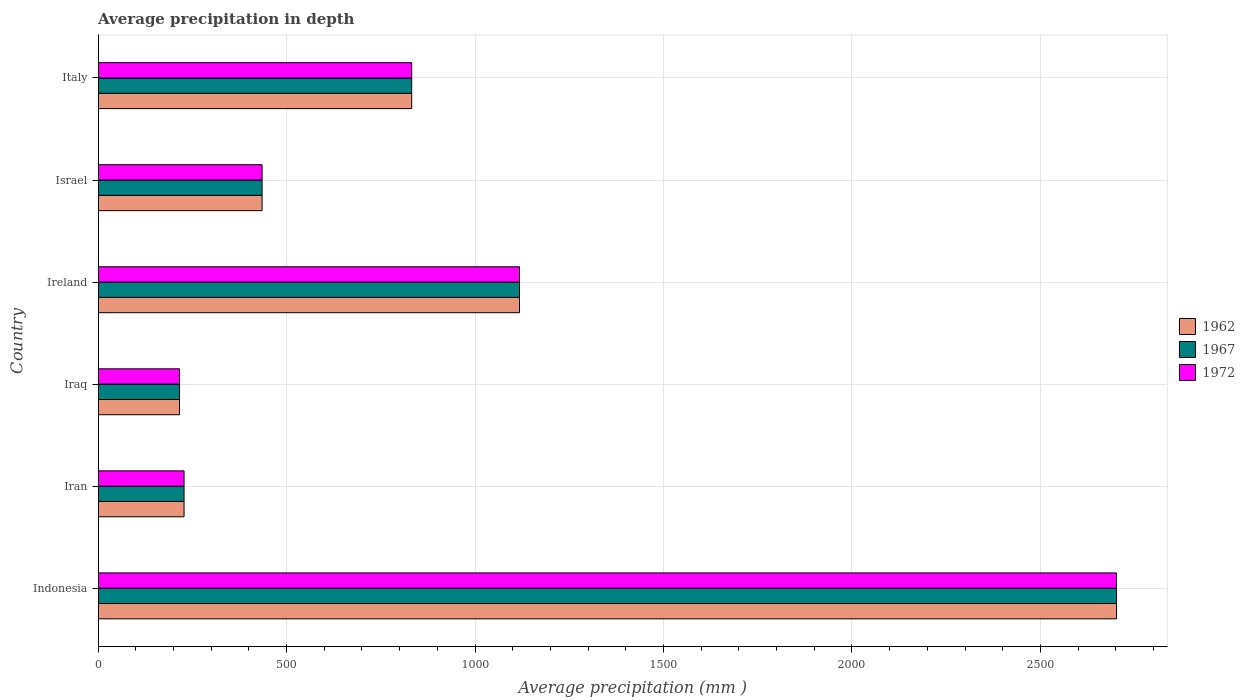How many groups of bars are there?
Give a very brief answer. 6. Are the number of bars on each tick of the Y-axis equal?
Provide a succinct answer. Yes. What is the label of the 6th group of bars from the top?
Provide a short and direct response. Indonesia. In how many cases, is the number of bars for a given country not equal to the number of legend labels?
Ensure brevity in your answer.  0. What is the average precipitation in 1962 in Indonesia?
Provide a succinct answer. 2702. Across all countries, what is the maximum average precipitation in 1967?
Provide a succinct answer. 2702. Across all countries, what is the minimum average precipitation in 1972?
Make the answer very short. 216. In which country was the average precipitation in 1962 minimum?
Provide a short and direct response. Iraq. What is the total average precipitation in 1967 in the graph?
Give a very brief answer. 5531. What is the difference between the average precipitation in 1962 in Iraq and that in Italy?
Make the answer very short. -616. What is the difference between the average precipitation in 1972 in Israel and the average precipitation in 1967 in Iraq?
Your response must be concise. 219. What is the average average precipitation in 1967 per country?
Provide a succinct answer. 921.83. What is the difference between the average precipitation in 1972 and average precipitation in 1962 in Iran?
Give a very brief answer. 0. What is the ratio of the average precipitation in 1962 in Iran to that in Israel?
Your answer should be compact. 0.52. What is the difference between the highest and the second highest average precipitation in 1962?
Keep it short and to the point. 1584. What is the difference between the highest and the lowest average precipitation in 1967?
Keep it short and to the point. 2486. Is the sum of the average precipitation in 1962 in Iran and Iraq greater than the maximum average precipitation in 1967 across all countries?
Provide a succinct answer. No. What does the 1st bar from the bottom in Iran represents?
Your answer should be very brief. 1962. How many bars are there?
Ensure brevity in your answer.  18. Are all the bars in the graph horizontal?
Keep it short and to the point. Yes. How many countries are there in the graph?
Offer a very short reply. 6. Does the graph contain any zero values?
Your response must be concise. No. Does the graph contain grids?
Offer a very short reply. Yes. How many legend labels are there?
Your response must be concise. 3. How are the legend labels stacked?
Offer a very short reply. Vertical. What is the title of the graph?
Give a very brief answer. Average precipitation in depth. Does "1997" appear as one of the legend labels in the graph?
Provide a succinct answer. No. What is the label or title of the X-axis?
Make the answer very short. Average precipitation (mm ). What is the label or title of the Y-axis?
Offer a terse response. Country. What is the Average precipitation (mm ) of 1962 in Indonesia?
Your answer should be very brief. 2702. What is the Average precipitation (mm ) in 1967 in Indonesia?
Give a very brief answer. 2702. What is the Average precipitation (mm ) of 1972 in Indonesia?
Offer a very short reply. 2702. What is the Average precipitation (mm ) of 1962 in Iran?
Keep it short and to the point. 228. What is the Average precipitation (mm ) of 1967 in Iran?
Your answer should be very brief. 228. What is the Average precipitation (mm ) in 1972 in Iran?
Ensure brevity in your answer.  228. What is the Average precipitation (mm ) of 1962 in Iraq?
Offer a very short reply. 216. What is the Average precipitation (mm ) in 1967 in Iraq?
Give a very brief answer. 216. What is the Average precipitation (mm ) in 1972 in Iraq?
Offer a terse response. 216. What is the Average precipitation (mm ) of 1962 in Ireland?
Provide a succinct answer. 1118. What is the Average precipitation (mm ) of 1967 in Ireland?
Provide a succinct answer. 1118. What is the Average precipitation (mm ) of 1972 in Ireland?
Offer a very short reply. 1118. What is the Average precipitation (mm ) of 1962 in Israel?
Offer a very short reply. 435. What is the Average precipitation (mm ) of 1967 in Israel?
Provide a succinct answer. 435. What is the Average precipitation (mm ) in 1972 in Israel?
Offer a terse response. 435. What is the Average precipitation (mm ) in 1962 in Italy?
Make the answer very short. 832. What is the Average precipitation (mm ) of 1967 in Italy?
Provide a succinct answer. 832. What is the Average precipitation (mm ) of 1972 in Italy?
Provide a succinct answer. 832. Across all countries, what is the maximum Average precipitation (mm ) in 1962?
Offer a very short reply. 2702. Across all countries, what is the maximum Average precipitation (mm ) of 1967?
Offer a very short reply. 2702. Across all countries, what is the maximum Average precipitation (mm ) of 1972?
Offer a very short reply. 2702. Across all countries, what is the minimum Average precipitation (mm ) of 1962?
Give a very brief answer. 216. Across all countries, what is the minimum Average precipitation (mm ) of 1967?
Provide a short and direct response. 216. Across all countries, what is the minimum Average precipitation (mm ) in 1972?
Give a very brief answer. 216. What is the total Average precipitation (mm ) of 1962 in the graph?
Make the answer very short. 5531. What is the total Average precipitation (mm ) in 1967 in the graph?
Give a very brief answer. 5531. What is the total Average precipitation (mm ) in 1972 in the graph?
Your answer should be compact. 5531. What is the difference between the Average precipitation (mm ) in 1962 in Indonesia and that in Iran?
Make the answer very short. 2474. What is the difference between the Average precipitation (mm ) in 1967 in Indonesia and that in Iran?
Provide a short and direct response. 2474. What is the difference between the Average precipitation (mm ) in 1972 in Indonesia and that in Iran?
Ensure brevity in your answer.  2474. What is the difference between the Average precipitation (mm ) of 1962 in Indonesia and that in Iraq?
Your answer should be compact. 2486. What is the difference between the Average precipitation (mm ) in 1967 in Indonesia and that in Iraq?
Your answer should be very brief. 2486. What is the difference between the Average precipitation (mm ) in 1972 in Indonesia and that in Iraq?
Make the answer very short. 2486. What is the difference between the Average precipitation (mm ) of 1962 in Indonesia and that in Ireland?
Provide a succinct answer. 1584. What is the difference between the Average precipitation (mm ) of 1967 in Indonesia and that in Ireland?
Offer a terse response. 1584. What is the difference between the Average precipitation (mm ) of 1972 in Indonesia and that in Ireland?
Provide a short and direct response. 1584. What is the difference between the Average precipitation (mm ) in 1962 in Indonesia and that in Israel?
Offer a very short reply. 2267. What is the difference between the Average precipitation (mm ) of 1967 in Indonesia and that in Israel?
Offer a very short reply. 2267. What is the difference between the Average precipitation (mm ) in 1972 in Indonesia and that in Israel?
Provide a succinct answer. 2267. What is the difference between the Average precipitation (mm ) of 1962 in Indonesia and that in Italy?
Offer a terse response. 1870. What is the difference between the Average precipitation (mm ) in 1967 in Indonesia and that in Italy?
Provide a succinct answer. 1870. What is the difference between the Average precipitation (mm ) in 1972 in Indonesia and that in Italy?
Offer a very short reply. 1870. What is the difference between the Average precipitation (mm ) in 1962 in Iran and that in Iraq?
Offer a terse response. 12. What is the difference between the Average precipitation (mm ) in 1967 in Iran and that in Iraq?
Give a very brief answer. 12. What is the difference between the Average precipitation (mm ) in 1962 in Iran and that in Ireland?
Offer a very short reply. -890. What is the difference between the Average precipitation (mm ) in 1967 in Iran and that in Ireland?
Ensure brevity in your answer.  -890. What is the difference between the Average precipitation (mm ) in 1972 in Iran and that in Ireland?
Make the answer very short. -890. What is the difference between the Average precipitation (mm ) of 1962 in Iran and that in Israel?
Offer a very short reply. -207. What is the difference between the Average precipitation (mm ) of 1967 in Iran and that in Israel?
Give a very brief answer. -207. What is the difference between the Average precipitation (mm ) of 1972 in Iran and that in Israel?
Provide a succinct answer. -207. What is the difference between the Average precipitation (mm ) in 1962 in Iran and that in Italy?
Provide a short and direct response. -604. What is the difference between the Average precipitation (mm ) in 1967 in Iran and that in Italy?
Provide a short and direct response. -604. What is the difference between the Average precipitation (mm ) in 1972 in Iran and that in Italy?
Offer a very short reply. -604. What is the difference between the Average precipitation (mm ) in 1962 in Iraq and that in Ireland?
Offer a very short reply. -902. What is the difference between the Average precipitation (mm ) of 1967 in Iraq and that in Ireland?
Provide a short and direct response. -902. What is the difference between the Average precipitation (mm ) of 1972 in Iraq and that in Ireland?
Keep it short and to the point. -902. What is the difference between the Average precipitation (mm ) in 1962 in Iraq and that in Israel?
Make the answer very short. -219. What is the difference between the Average precipitation (mm ) in 1967 in Iraq and that in Israel?
Offer a terse response. -219. What is the difference between the Average precipitation (mm ) of 1972 in Iraq and that in Israel?
Provide a short and direct response. -219. What is the difference between the Average precipitation (mm ) of 1962 in Iraq and that in Italy?
Your answer should be very brief. -616. What is the difference between the Average precipitation (mm ) in 1967 in Iraq and that in Italy?
Offer a very short reply. -616. What is the difference between the Average precipitation (mm ) in 1972 in Iraq and that in Italy?
Offer a terse response. -616. What is the difference between the Average precipitation (mm ) in 1962 in Ireland and that in Israel?
Your response must be concise. 683. What is the difference between the Average precipitation (mm ) of 1967 in Ireland and that in Israel?
Provide a short and direct response. 683. What is the difference between the Average precipitation (mm ) in 1972 in Ireland and that in Israel?
Provide a short and direct response. 683. What is the difference between the Average precipitation (mm ) in 1962 in Ireland and that in Italy?
Offer a terse response. 286. What is the difference between the Average precipitation (mm ) of 1967 in Ireland and that in Italy?
Offer a terse response. 286. What is the difference between the Average precipitation (mm ) in 1972 in Ireland and that in Italy?
Offer a very short reply. 286. What is the difference between the Average precipitation (mm ) of 1962 in Israel and that in Italy?
Your answer should be very brief. -397. What is the difference between the Average precipitation (mm ) in 1967 in Israel and that in Italy?
Your response must be concise. -397. What is the difference between the Average precipitation (mm ) of 1972 in Israel and that in Italy?
Make the answer very short. -397. What is the difference between the Average precipitation (mm ) in 1962 in Indonesia and the Average precipitation (mm ) in 1967 in Iran?
Your response must be concise. 2474. What is the difference between the Average precipitation (mm ) of 1962 in Indonesia and the Average precipitation (mm ) of 1972 in Iran?
Offer a very short reply. 2474. What is the difference between the Average precipitation (mm ) in 1967 in Indonesia and the Average precipitation (mm ) in 1972 in Iran?
Give a very brief answer. 2474. What is the difference between the Average precipitation (mm ) in 1962 in Indonesia and the Average precipitation (mm ) in 1967 in Iraq?
Your response must be concise. 2486. What is the difference between the Average precipitation (mm ) of 1962 in Indonesia and the Average precipitation (mm ) of 1972 in Iraq?
Offer a very short reply. 2486. What is the difference between the Average precipitation (mm ) of 1967 in Indonesia and the Average precipitation (mm ) of 1972 in Iraq?
Give a very brief answer. 2486. What is the difference between the Average precipitation (mm ) of 1962 in Indonesia and the Average precipitation (mm ) of 1967 in Ireland?
Your answer should be compact. 1584. What is the difference between the Average precipitation (mm ) in 1962 in Indonesia and the Average precipitation (mm ) in 1972 in Ireland?
Your response must be concise. 1584. What is the difference between the Average precipitation (mm ) in 1967 in Indonesia and the Average precipitation (mm ) in 1972 in Ireland?
Provide a short and direct response. 1584. What is the difference between the Average precipitation (mm ) in 1962 in Indonesia and the Average precipitation (mm ) in 1967 in Israel?
Provide a short and direct response. 2267. What is the difference between the Average precipitation (mm ) of 1962 in Indonesia and the Average precipitation (mm ) of 1972 in Israel?
Provide a succinct answer. 2267. What is the difference between the Average precipitation (mm ) in 1967 in Indonesia and the Average precipitation (mm ) in 1972 in Israel?
Ensure brevity in your answer.  2267. What is the difference between the Average precipitation (mm ) in 1962 in Indonesia and the Average precipitation (mm ) in 1967 in Italy?
Give a very brief answer. 1870. What is the difference between the Average precipitation (mm ) of 1962 in Indonesia and the Average precipitation (mm ) of 1972 in Italy?
Give a very brief answer. 1870. What is the difference between the Average precipitation (mm ) in 1967 in Indonesia and the Average precipitation (mm ) in 1972 in Italy?
Give a very brief answer. 1870. What is the difference between the Average precipitation (mm ) of 1962 in Iran and the Average precipitation (mm ) of 1972 in Iraq?
Provide a short and direct response. 12. What is the difference between the Average precipitation (mm ) in 1962 in Iran and the Average precipitation (mm ) in 1967 in Ireland?
Keep it short and to the point. -890. What is the difference between the Average precipitation (mm ) in 1962 in Iran and the Average precipitation (mm ) in 1972 in Ireland?
Your answer should be compact. -890. What is the difference between the Average precipitation (mm ) in 1967 in Iran and the Average precipitation (mm ) in 1972 in Ireland?
Your answer should be compact. -890. What is the difference between the Average precipitation (mm ) of 1962 in Iran and the Average precipitation (mm ) of 1967 in Israel?
Make the answer very short. -207. What is the difference between the Average precipitation (mm ) of 1962 in Iran and the Average precipitation (mm ) of 1972 in Israel?
Ensure brevity in your answer.  -207. What is the difference between the Average precipitation (mm ) in 1967 in Iran and the Average precipitation (mm ) in 1972 in Israel?
Give a very brief answer. -207. What is the difference between the Average precipitation (mm ) of 1962 in Iran and the Average precipitation (mm ) of 1967 in Italy?
Make the answer very short. -604. What is the difference between the Average precipitation (mm ) in 1962 in Iran and the Average precipitation (mm ) in 1972 in Italy?
Your response must be concise. -604. What is the difference between the Average precipitation (mm ) in 1967 in Iran and the Average precipitation (mm ) in 1972 in Italy?
Offer a terse response. -604. What is the difference between the Average precipitation (mm ) of 1962 in Iraq and the Average precipitation (mm ) of 1967 in Ireland?
Provide a short and direct response. -902. What is the difference between the Average precipitation (mm ) of 1962 in Iraq and the Average precipitation (mm ) of 1972 in Ireland?
Keep it short and to the point. -902. What is the difference between the Average precipitation (mm ) of 1967 in Iraq and the Average precipitation (mm ) of 1972 in Ireland?
Make the answer very short. -902. What is the difference between the Average precipitation (mm ) of 1962 in Iraq and the Average precipitation (mm ) of 1967 in Israel?
Your answer should be compact. -219. What is the difference between the Average precipitation (mm ) of 1962 in Iraq and the Average precipitation (mm ) of 1972 in Israel?
Your answer should be compact. -219. What is the difference between the Average precipitation (mm ) of 1967 in Iraq and the Average precipitation (mm ) of 1972 in Israel?
Your answer should be compact. -219. What is the difference between the Average precipitation (mm ) in 1962 in Iraq and the Average precipitation (mm ) in 1967 in Italy?
Your response must be concise. -616. What is the difference between the Average precipitation (mm ) of 1962 in Iraq and the Average precipitation (mm ) of 1972 in Italy?
Your answer should be compact. -616. What is the difference between the Average precipitation (mm ) in 1967 in Iraq and the Average precipitation (mm ) in 1972 in Italy?
Keep it short and to the point. -616. What is the difference between the Average precipitation (mm ) of 1962 in Ireland and the Average precipitation (mm ) of 1967 in Israel?
Your answer should be very brief. 683. What is the difference between the Average precipitation (mm ) of 1962 in Ireland and the Average precipitation (mm ) of 1972 in Israel?
Ensure brevity in your answer.  683. What is the difference between the Average precipitation (mm ) in 1967 in Ireland and the Average precipitation (mm ) in 1972 in Israel?
Offer a terse response. 683. What is the difference between the Average precipitation (mm ) of 1962 in Ireland and the Average precipitation (mm ) of 1967 in Italy?
Your answer should be very brief. 286. What is the difference between the Average precipitation (mm ) of 1962 in Ireland and the Average precipitation (mm ) of 1972 in Italy?
Give a very brief answer. 286. What is the difference between the Average precipitation (mm ) in 1967 in Ireland and the Average precipitation (mm ) in 1972 in Italy?
Keep it short and to the point. 286. What is the difference between the Average precipitation (mm ) of 1962 in Israel and the Average precipitation (mm ) of 1967 in Italy?
Make the answer very short. -397. What is the difference between the Average precipitation (mm ) of 1962 in Israel and the Average precipitation (mm ) of 1972 in Italy?
Provide a short and direct response. -397. What is the difference between the Average precipitation (mm ) in 1967 in Israel and the Average precipitation (mm ) in 1972 in Italy?
Your answer should be very brief. -397. What is the average Average precipitation (mm ) in 1962 per country?
Provide a short and direct response. 921.83. What is the average Average precipitation (mm ) of 1967 per country?
Offer a terse response. 921.83. What is the average Average precipitation (mm ) of 1972 per country?
Ensure brevity in your answer.  921.83. What is the difference between the Average precipitation (mm ) in 1967 and Average precipitation (mm ) in 1972 in Indonesia?
Provide a short and direct response. 0. What is the difference between the Average precipitation (mm ) of 1962 and Average precipitation (mm ) of 1967 in Iran?
Provide a succinct answer. 0. What is the difference between the Average precipitation (mm ) in 1962 and Average precipitation (mm ) in 1967 in Iraq?
Ensure brevity in your answer.  0. What is the difference between the Average precipitation (mm ) of 1962 and Average precipitation (mm ) of 1967 in Ireland?
Offer a very short reply. 0. What is the difference between the Average precipitation (mm ) in 1967 and Average precipitation (mm ) in 1972 in Ireland?
Offer a very short reply. 0. What is the difference between the Average precipitation (mm ) in 1967 and Average precipitation (mm ) in 1972 in Israel?
Keep it short and to the point. 0. What is the difference between the Average precipitation (mm ) of 1962 and Average precipitation (mm ) of 1972 in Italy?
Your answer should be very brief. 0. What is the difference between the Average precipitation (mm ) of 1967 and Average precipitation (mm ) of 1972 in Italy?
Your answer should be very brief. 0. What is the ratio of the Average precipitation (mm ) of 1962 in Indonesia to that in Iran?
Provide a short and direct response. 11.85. What is the ratio of the Average precipitation (mm ) in 1967 in Indonesia to that in Iran?
Your response must be concise. 11.85. What is the ratio of the Average precipitation (mm ) of 1972 in Indonesia to that in Iran?
Your response must be concise. 11.85. What is the ratio of the Average precipitation (mm ) of 1962 in Indonesia to that in Iraq?
Your answer should be compact. 12.51. What is the ratio of the Average precipitation (mm ) of 1967 in Indonesia to that in Iraq?
Provide a succinct answer. 12.51. What is the ratio of the Average precipitation (mm ) in 1972 in Indonesia to that in Iraq?
Provide a short and direct response. 12.51. What is the ratio of the Average precipitation (mm ) in 1962 in Indonesia to that in Ireland?
Your answer should be compact. 2.42. What is the ratio of the Average precipitation (mm ) in 1967 in Indonesia to that in Ireland?
Provide a succinct answer. 2.42. What is the ratio of the Average precipitation (mm ) in 1972 in Indonesia to that in Ireland?
Offer a very short reply. 2.42. What is the ratio of the Average precipitation (mm ) of 1962 in Indonesia to that in Israel?
Make the answer very short. 6.21. What is the ratio of the Average precipitation (mm ) in 1967 in Indonesia to that in Israel?
Provide a short and direct response. 6.21. What is the ratio of the Average precipitation (mm ) in 1972 in Indonesia to that in Israel?
Provide a succinct answer. 6.21. What is the ratio of the Average precipitation (mm ) of 1962 in Indonesia to that in Italy?
Offer a terse response. 3.25. What is the ratio of the Average precipitation (mm ) in 1967 in Indonesia to that in Italy?
Your answer should be compact. 3.25. What is the ratio of the Average precipitation (mm ) in 1972 in Indonesia to that in Italy?
Provide a short and direct response. 3.25. What is the ratio of the Average precipitation (mm ) in 1962 in Iran to that in Iraq?
Your answer should be compact. 1.06. What is the ratio of the Average precipitation (mm ) of 1967 in Iran to that in Iraq?
Keep it short and to the point. 1.06. What is the ratio of the Average precipitation (mm ) of 1972 in Iran to that in Iraq?
Give a very brief answer. 1.06. What is the ratio of the Average precipitation (mm ) in 1962 in Iran to that in Ireland?
Keep it short and to the point. 0.2. What is the ratio of the Average precipitation (mm ) of 1967 in Iran to that in Ireland?
Offer a very short reply. 0.2. What is the ratio of the Average precipitation (mm ) in 1972 in Iran to that in Ireland?
Offer a terse response. 0.2. What is the ratio of the Average precipitation (mm ) of 1962 in Iran to that in Israel?
Give a very brief answer. 0.52. What is the ratio of the Average precipitation (mm ) of 1967 in Iran to that in Israel?
Your answer should be very brief. 0.52. What is the ratio of the Average precipitation (mm ) of 1972 in Iran to that in Israel?
Your answer should be very brief. 0.52. What is the ratio of the Average precipitation (mm ) in 1962 in Iran to that in Italy?
Make the answer very short. 0.27. What is the ratio of the Average precipitation (mm ) of 1967 in Iran to that in Italy?
Make the answer very short. 0.27. What is the ratio of the Average precipitation (mm ) in 1972 in Iran to that in Italy?
Offer a terse response. 0.27. What is the ratio of the Average precipitation (mm ) in 1962 in Iraq to that in Ireland?
Provide a succinct answer. 0.19. What is the ratio of the Average precipitation (mm ) in 1967 in Iraq to that in Ireland?
Provide a short and direct response. 0.19. What is the ratio of the Average precipitation (mm ) in 1972 in Iraq to that in Ireland?
Make the answer very short. 0.19. What is the ratio of the Average precipitation (mm ) in 1962 in Iraq to that in Israel?
Ensure brevity in your answer.  0.5. What is the ratio of the Average precipitation (mm ) in 1967 in Iraq to that in Israel?
Give a very brief answer. 0.5. What is the ratio of the Average precipitation (mm ) of 1972 in Iraq to that in Israel?
Give a very brief answer. 0.5. What is the ratio of the Average precipitation (mm ) in 1962 in Iraq to that in Italy?
Provide a succinct answer. 0.26. What is the ratio of the Average precipitation (mm ) of 1967 in Iraq to that in Italy?
Your response must be concise. 0.26. What is the ratio of the Average precipitation (mm ) in 1972 in Iraq to that in Italy?
Ensure brevity in your answer.  0.26. What is the ratio of the Average precipitation (mm ) of 1962 in Ireland to that in Israel?
Ensure brevity in your answer.  2.57. What is the ratio of the Average precipitation (mm ) of 1967 in Ireland to that in Israel?
Your answer should be very brief. 2.57. What is the ratio of the Average precipitation (mm ) in 1972 in Ireland to that in Israel?
Your answer should be compact. 2.57. What is the ratio of the Average precipitation (mm ) in 1962 in Ireland to that in Italy?
Ensure brevity in your answer.  1.34. What is the ratio of the Average precipitation (mm ) in 1967 in Ireland to that in Italy?
Ensure brevity in your answer.  1.34. What is the ratio of the Average precipitation (mm ) of 1972 in Ireland to that in Italy?
Give a very brief answer. 1.34. What is the ratio of the Average precipitation (mm ) of 1962 in Israel to that in Italy?
Provide a short and direct response. 0.52. What is the ratio of the Average precipitation (mm ) of 1967 in Israel to that in Italy?
Provide a short and direct response. 0.52. What is the ratio of the Average precipitation (mm ) in 1972 in Israel to that in Italy?
Your answer should be compact. 0.52. What is the difference between the highest and the second highest Average precipitation (mm ) in 1962?
Offer a terse response. 1584. What is the difference between the highest and the second highest Average precipitation (mm ) in 1967?
Offer a terse response. 1584. What is the difference between the highest and the second highest Average precipitation (mm ) of 1972?
Offer a very short reply. 1584. What is the difference between the highest and the lowest Average precipitation (mm ) of 1962?
Your response must be concise. 2486. What is the difference between the highest and the lowest Average precipitation (mm ) of 1967?
Ensure brevity in your answer.  2486. What is the difference between the highest and the lowest Average precipitation (mm ) of 1972?
Provide a short and direct response. 2486. 